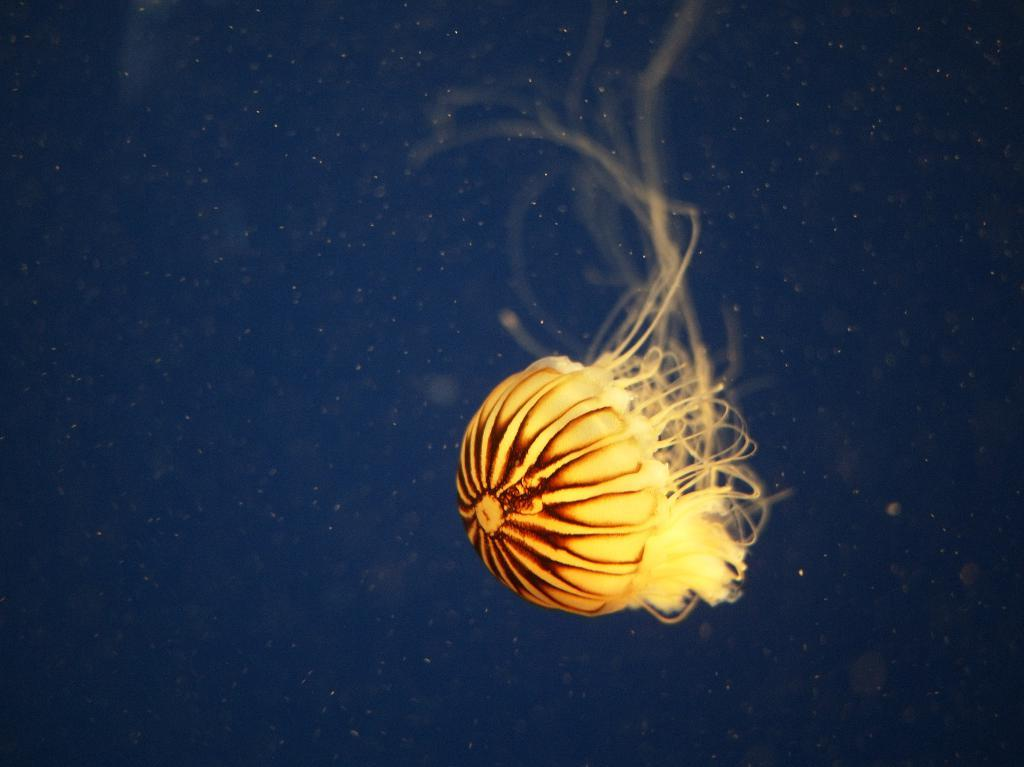What type of animal is in the image? There is a jellyfish in the image. Where is the jellyfish located? The jellyfish is in the water. How many chickens are visible in the image? There are no chickens present in the image; it features a jellyfish in the water. What type of insects can be seen interacting with the jellyfish in the image? There are no insects, such as ants, visible in the image; it only features a jellyfish in the water. 